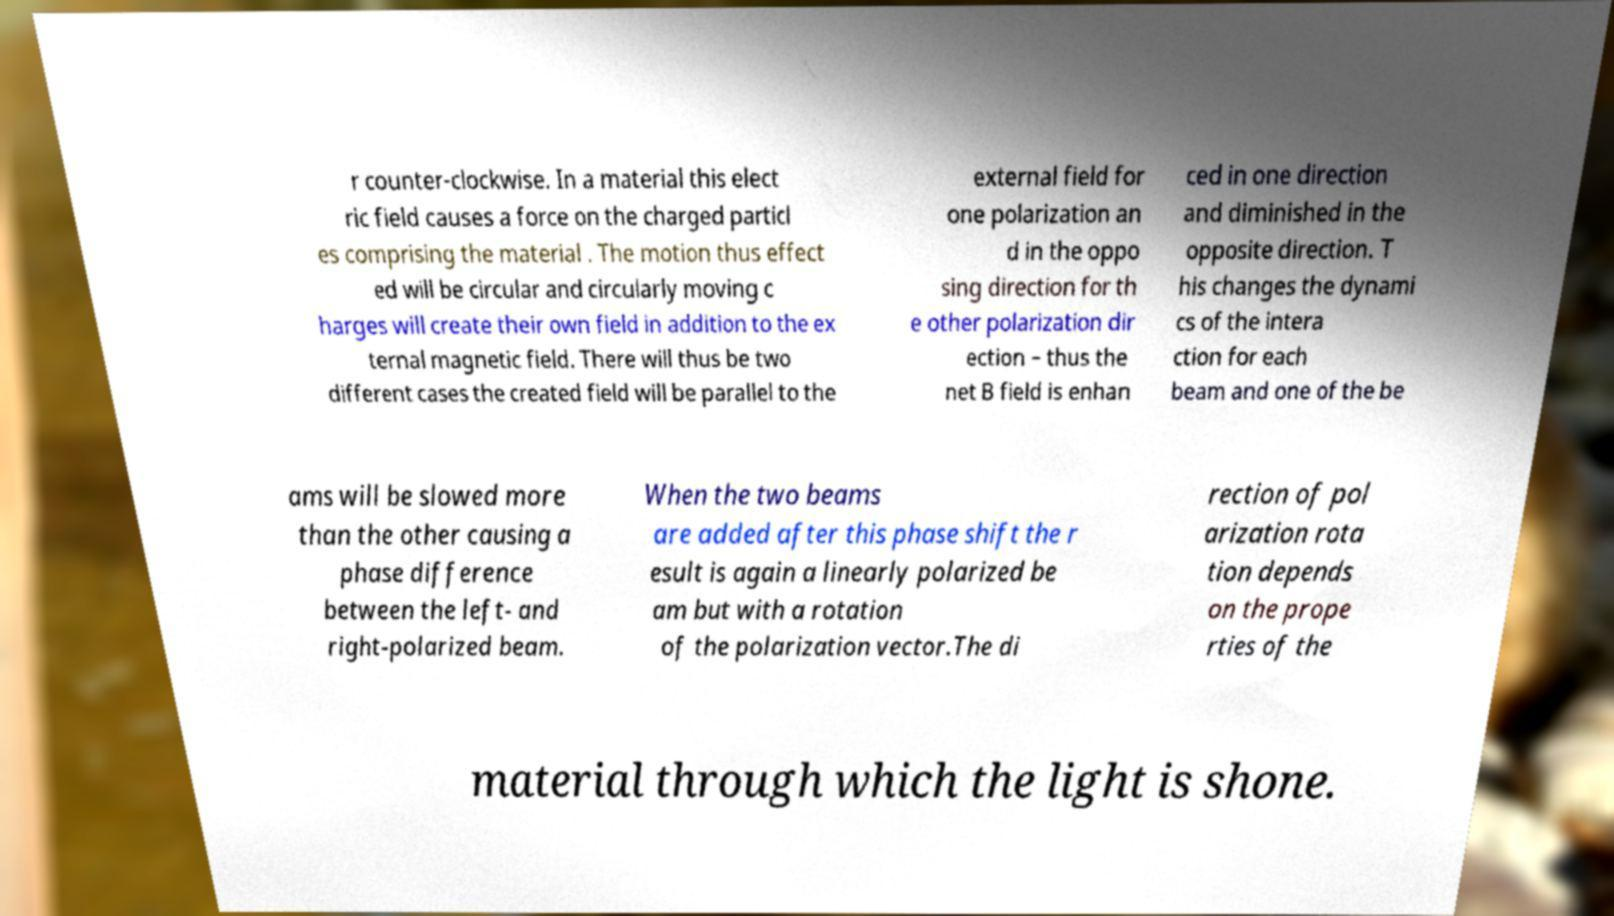I need the written content from this picture converted into text. Can you do that? r counter-clockwise. In a material this elect ric field causes a force on the charged particl es comprising the material . The motion thus effect ed will be circular and circularly moving c harges will create their own field in addition to the ex ternal magnetic field. There will thus be two different cases the created field will be parallel to the external field for one polarization an d in the oppo sing direction for th e other polarization dir ection – thus the net B field is enhan ced in one direction and diminished in the opposite direction. T his changes the dynami cs of the intera ction for each beam and one of the be ams will be slowed more than the other causing a phase difference between the left- and right-polarized beam. When the two beams are added after this phase shift the r esult is again a linearly polarized be am but with a rotation of the polarization vector.The di rection of pol arization rota tion depends on the prope rties of the material through which the light is shone. 